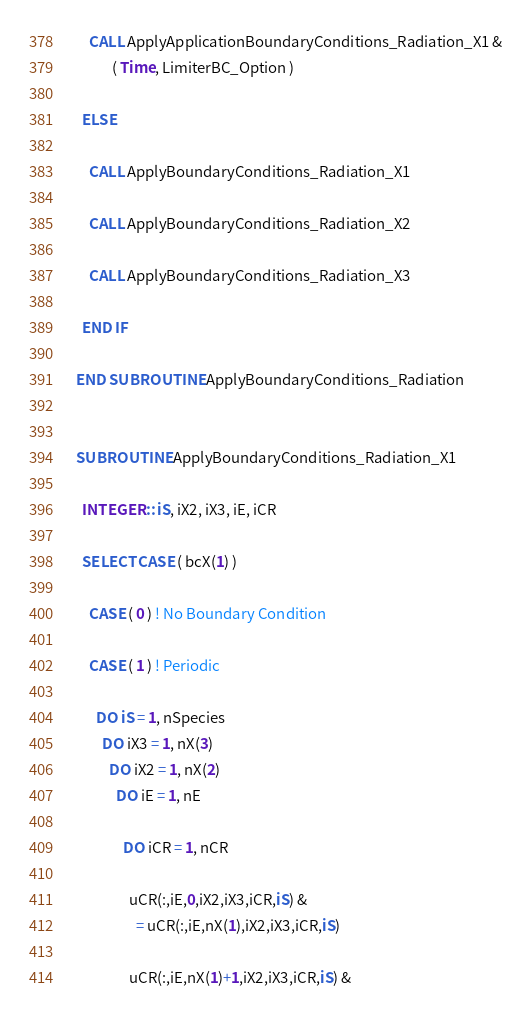Convert code to text. <code><loc_0><loc_0><loc_500><loc_500><_FORTRAN_>
      CALL ApplyApplicationBoundaryConditions_Radiation_X1 &
             ( Time, LimiterBC_Option )

    ELSE

      CALL ApplyBoundaryConditions_Radiation_X1

      CALL ApplyBoundaryConditions_Radiation_X2

      CALL ApplyBoundaryConditions_Radiation_X3

    END IF

  END SUBROUTINE ApplyBoundaryConditions_Radiation


  SUBROUTINE ApplyBoundaryConditions_Radiation_X1

    INTEGER :: iS, iX2, iX3, iE, iCR

    SELECT CASE ( bcX(1) )

      CASE ( 0 ) ! No Boundary Condition

      CASE ( 1 ) ! Periodic

        DO iS = 1, nSpecies
          DO iX3 = 1, nX(3)
            DO iX2 = 1, nX(2)
              DO iE = 1, nE

                DO iCR = 1, nCR

                  uCR(:,iE,0,iX2,iX3,iCR,iS) &
                    = uCR(:,iE,nX(1),iX2,iX3,iCR,iS)

                  uCR(:,iE,nX(1)+1,iX2,iX3,iCR,iS) &</code> 